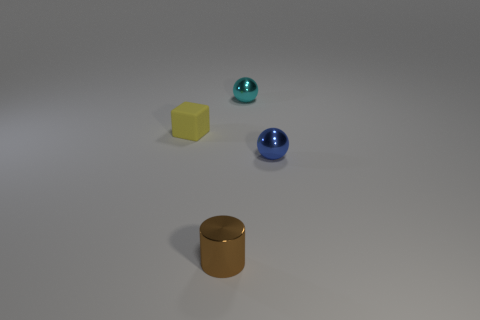Add 3 tiny blue metal objects. How many objects exist? 7 Subtract all blocks. How many objects are left? 3 Subtract all tiny blocks. Subtract all tiny metallic things. How many objects are left? 0 Add 4 brown cylinders. How many brown cylinders are left? 5 Add 3 green matte balls. How many green matte balls exist? 3 Subtract 0 brown spheres. How many objects are left? 4 